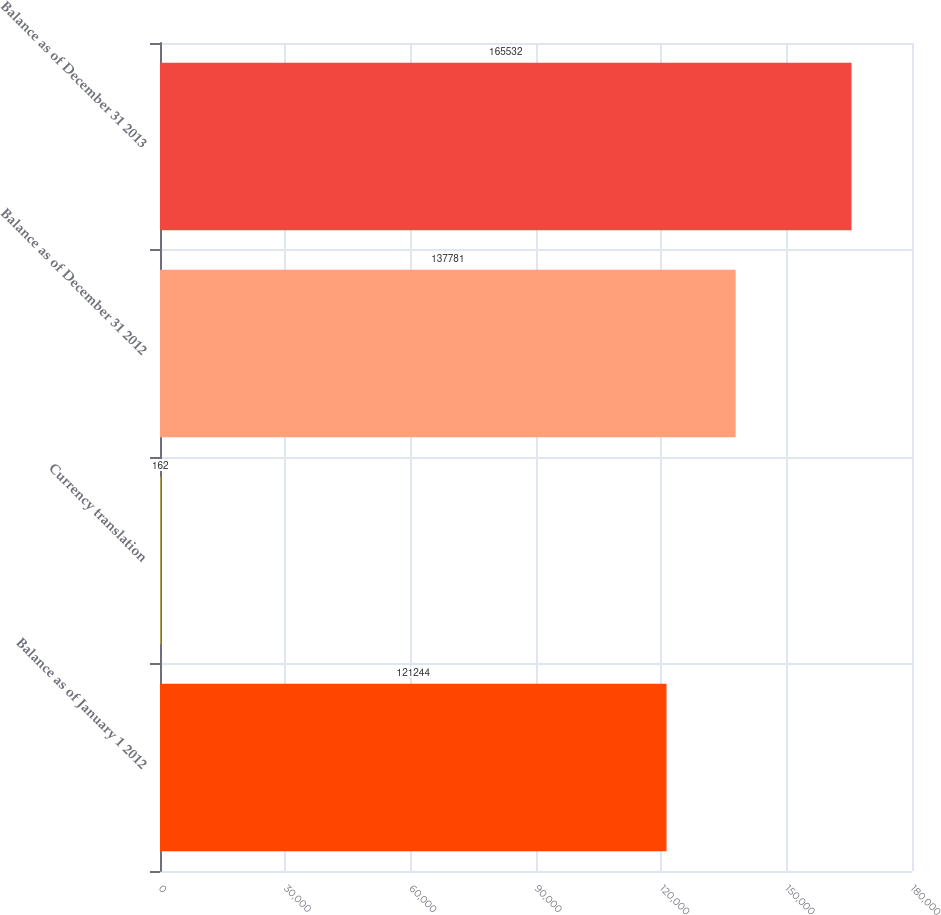Convert chart. <chart><loc_0><loc_0><loc_500><loc_500><bar_chart><fcel>Balance as of January 1 2012<fcel>Currency translation<fcel>Balance as of December 31 2012<fcel>Balance as of December 31 2013<nl><fcel>121244<fcel>162<fcel>137781<fcel>165532<nl></chart> 